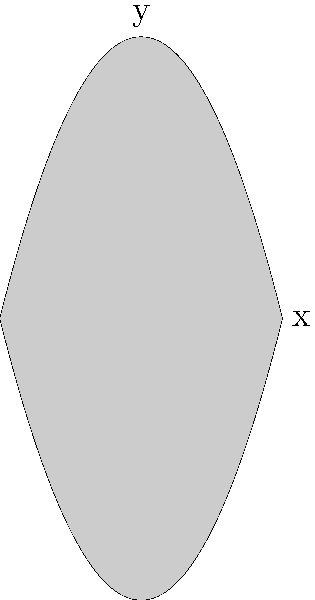In the coordinate system above, the shaded area represents societal norms. How can you use the concept of negative space to critique these norms and illustrate societal voids? Express your answer in terms of the mathematical representation of the shaded and unshaded areas. 1. Observe the shaded area: It's bounded by two parabolas, $y = x^2 - 4$ and $y = -x^2 + 4$.

2. The shaded area represents societal norms, conformity, or expectations.

3. The unshaded areas (negative space) represent societal voids or areas of non-conformity.

4. Mathematically, the shaded area can be expressed as:
   $$ \int_{-2}^2 ((-x^2+4) - (x^2-4)) dx $$

5. The unshaded areas (negative space) are everything outside this integral.

6. To critique societal norms, focus on the negative space:
   a) Above the upper parabola: $y > -x^2 + 4$
   b) Below the lower parabola: $y < x^2 - 4$

7. These inequalities represent areas where individuals or ideas exist outside societal norms.

8. By emphasizing these areas in your artwork, you draw attention to what society overlooks or excludes.

9. The contrast between the finite shaded area and the infinite unshaded area can symbolize the limitless potential outside societal constraints.
Answer: Emphasize $y > -x^2 + 4$ and $y < x^2 - 4$ to highlight societal voids. 